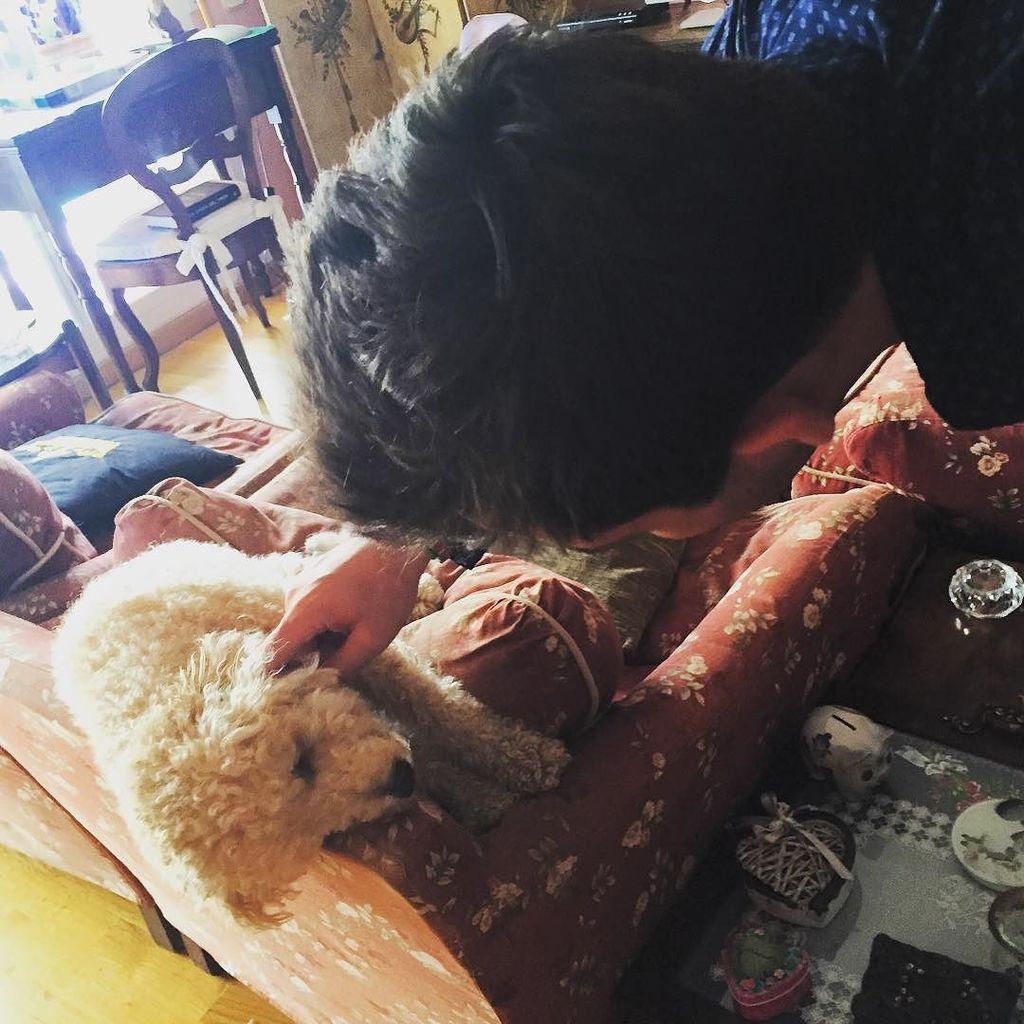Can you describe this image briefly? In this image we can see a person standing on the floor, a dog lying on the sofa, table, chair, pillows and some objects on the carpet. 